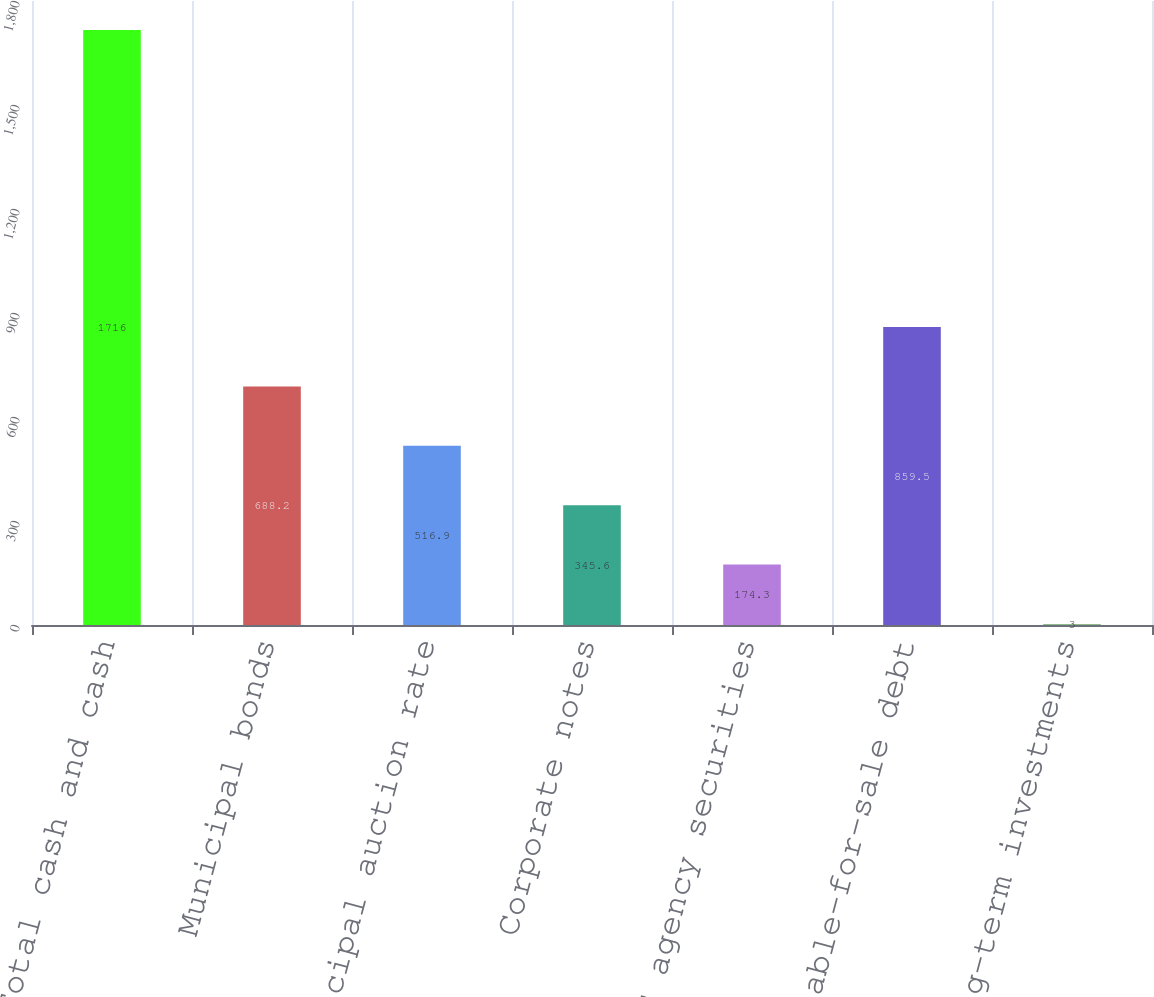Convert chart to OTSL. <chart><loc_0><loc_0><loc_500><loc_500><bar_chart><fcel>Total cash and cash<fcel>Municipal bonds<fcel>Municipal auction rate<fcel>Corporate notes<fcel>US agency securities<fcel>Total available-for-sale debt<fcel>Other long-term investments<nl><fcel>1716<fcel>688.2<fcel>516.9<fcel>345.6<fcel>174.3<fcel>859.5<fcel>3<nl></chart> 